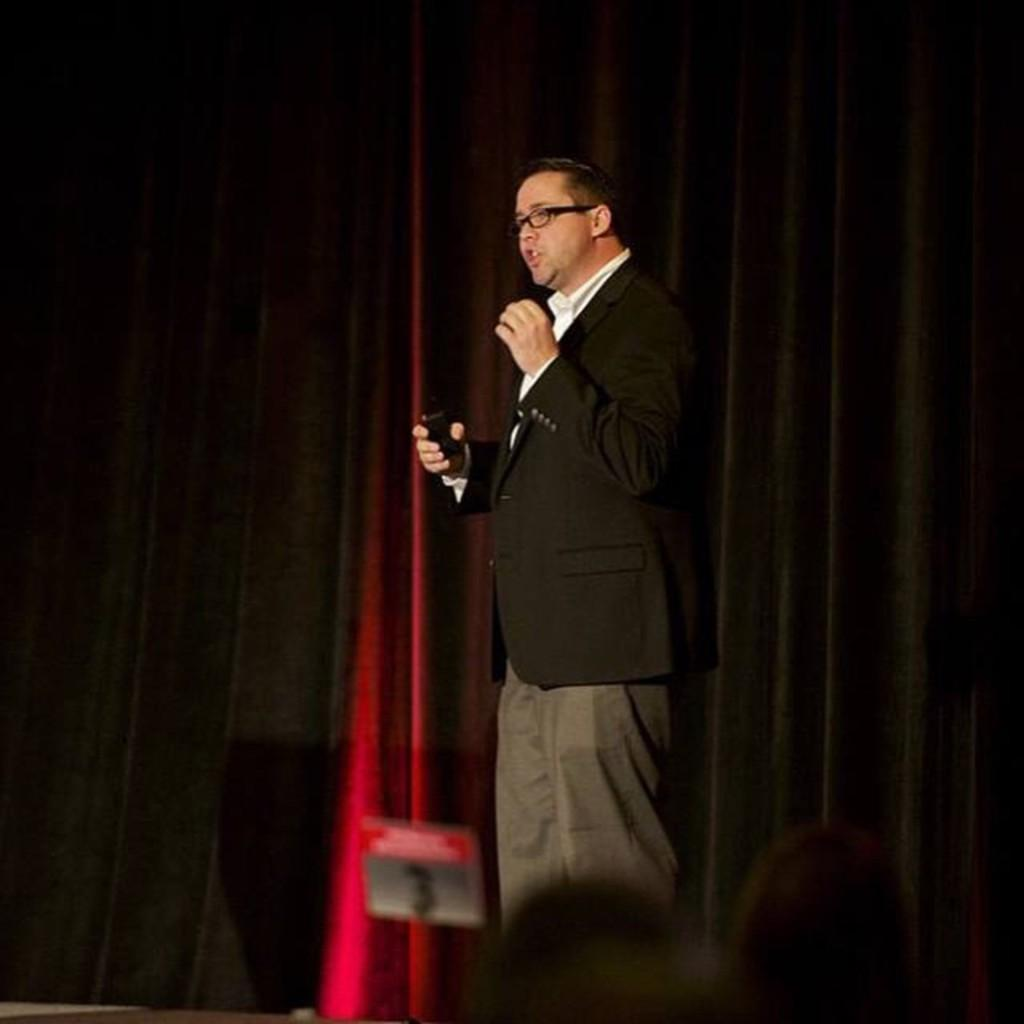What can be seen in the image? There is a person in the image. Can you describe the person's appearance? The person is wearing clothes and standing. What is the person holding in the image? The person is holding an object. What can be seen in the background of the image? There are curtains visible in the image. What type of cake is being served on the clam in the image? There is no cake or clam present in the image. How many bananas are visible on the person's head in the image? There are no bananas visible on the person's head in the image. 